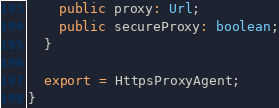Convert code to text. <code><loc_0><loc_0><loc_500><loc_500><_TypeScript_>    public proxy: Url;
    public secureProxy: boolean;
  }

  export = HttpsProxyAgent;
}

</code> 